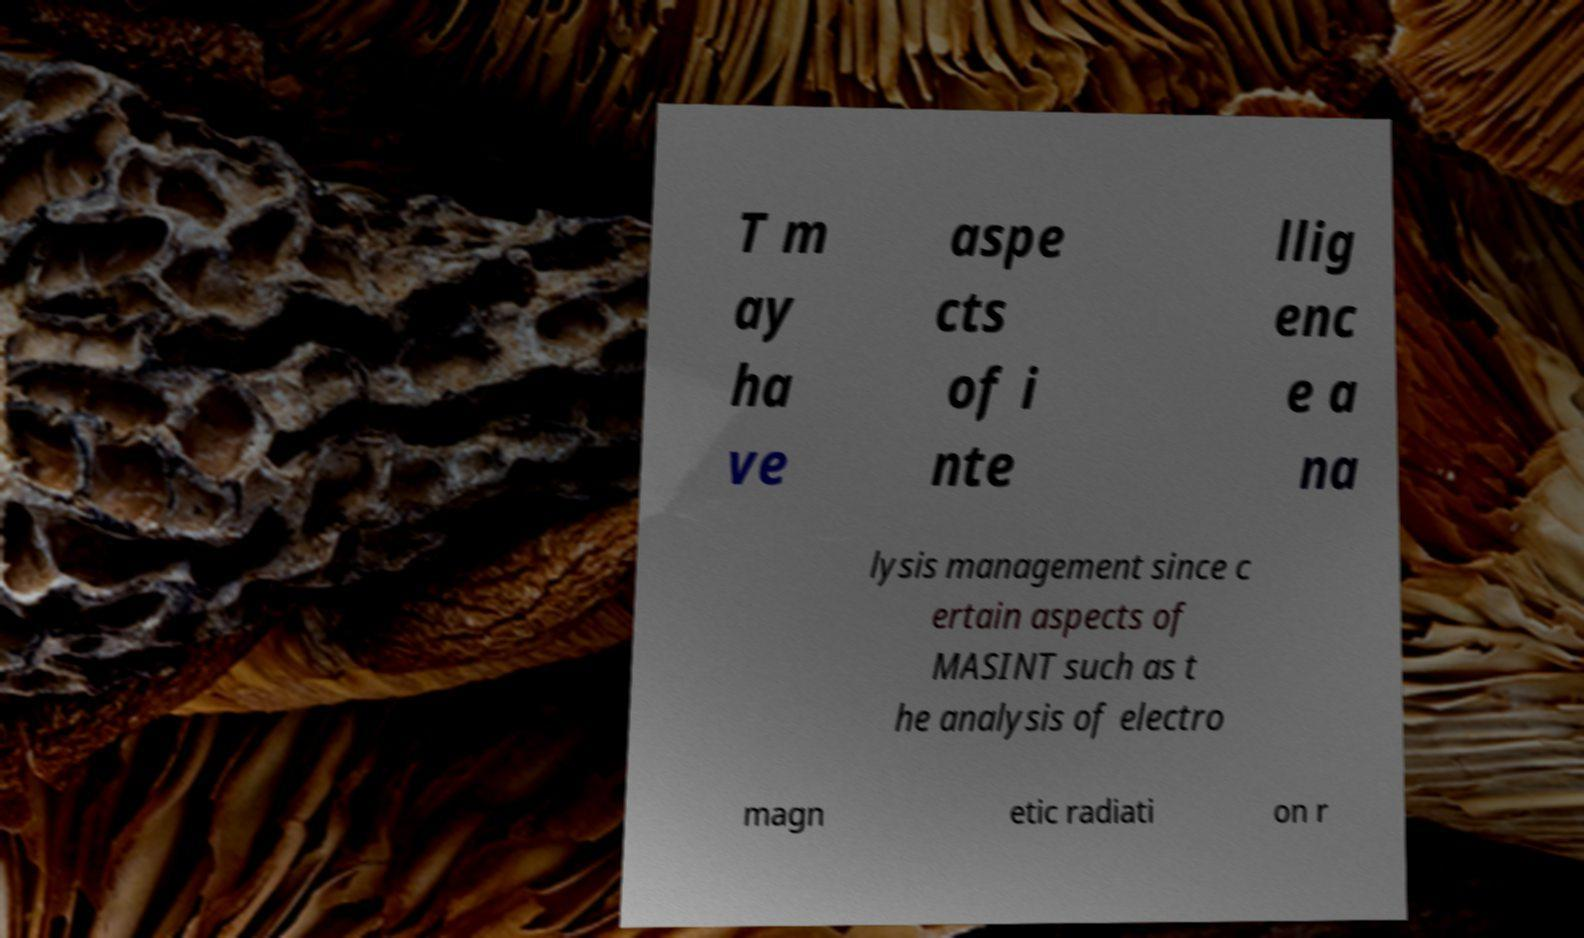Please identify and transcribe the text found in this image. T m ay ha ve aspe cts of i nte llig enc e a na lysis management since c ertain aspects of MASINT such as t he analysis of electro magn etic radiati on r 